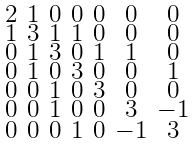<formula> <loc_0><loc_0><loc_500><loc_500>\begin{smallmatrix} 2 & 1 & 0 & 0 & 0 & 0 & 0 \\ 1 & 3 & 1 & 1 & 0 & 0 & 0 \\ 0 & 1 & 3 & 0 & 1 & 1 & 0 \\ 0 & 1 & 0 & 3 & 0 & 0 & 1 \\ 0 & 0 & 1 & 0 & 3 & 0 & 0 \\ 0 & 0 & 1 & 0 & 0 & 3 & - 1 \\ 0 & 0 & 0 & 1 & 0 & - 1 & 3 \end{smallmatrix}</formula> 